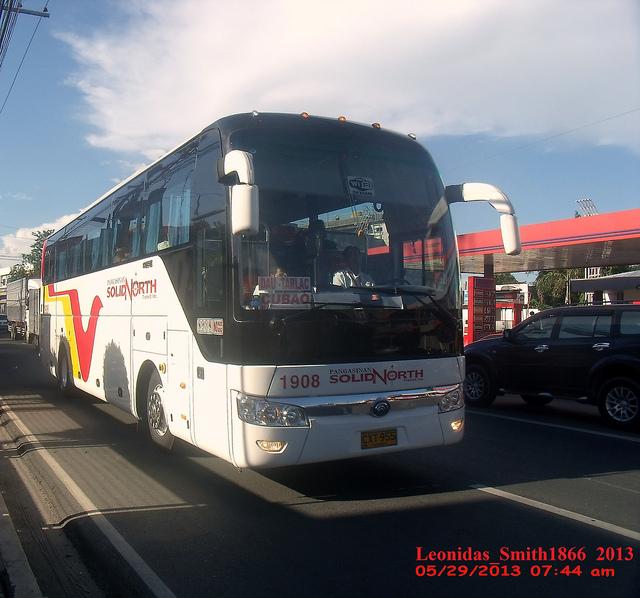Are the people in this picture on a bus?
Quick response, please. Yes. Where are the bus occupants from?
Quick response, please. North. What number is on the front of the bus?
Short answer required. 1908. What is the first letter of the trucks license?
Quick response, please. C. Is this a US license plate?
Quick response, please. Yes. Where is this bus located?
Give a very brief answer. On street. Are the stripes on the side of the bus shaped like the letter q?
Short answer required. No. When was this picture taken?
Concise answer only. 05/29/2013. 